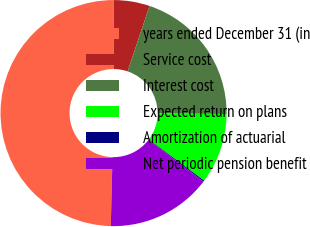<chart> <loc_0><loc_0><loc_500><loc_500><pie_chart><fcel>years ended December 31 (in<fcel>Service cost<fcel>Interest cost<fcel>Expected return on plans<fcel>Amortization of actuarial<fcel>Net periodic pension benefit<nl><fcel>49.65%<fcel>5.12%<fcel>19.97%<fcel>10.07%<fcel>0.17%<fcel>15.02%<nl></chart> 